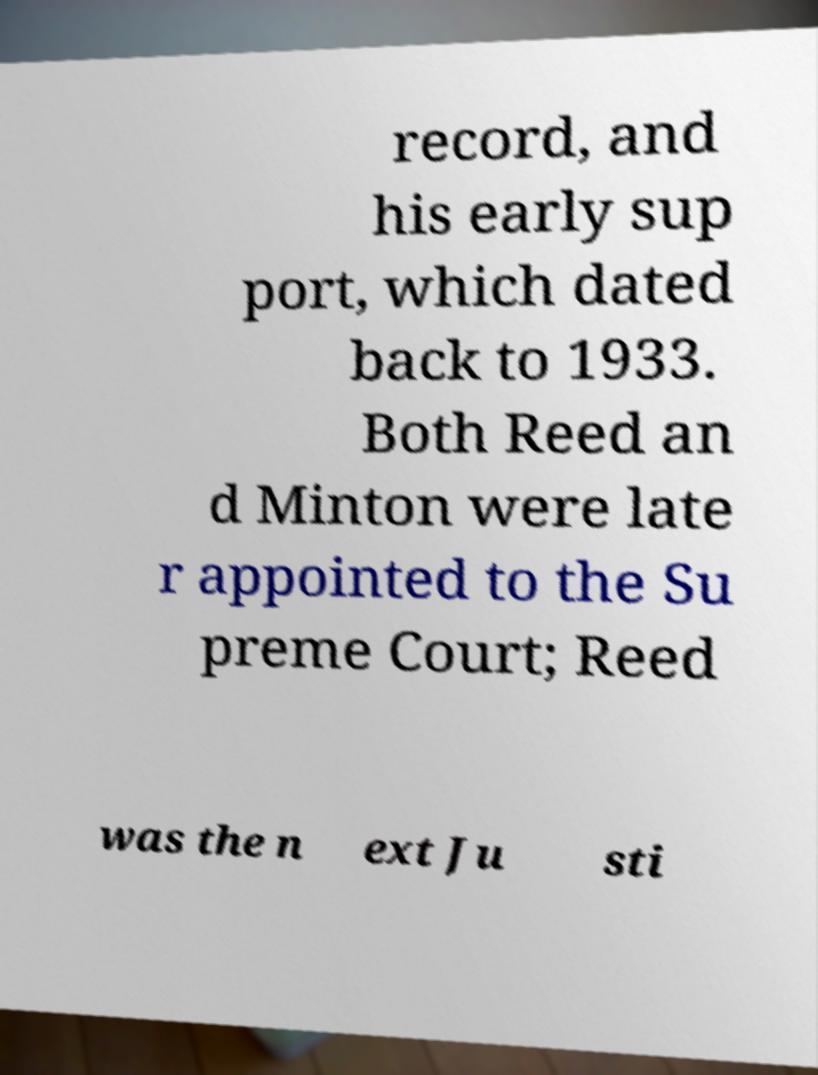Can you accurately transcribe the text from the provided image for me? record, and his early sup port, which dated back to 1933. Both Reed an d Minton were late r appointed to the Su preme Court; Reed was the n ext Ju sti 